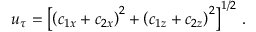Convert formula to latex. <formula><loc_0><loc_0><loc_500><loc_500>u _ { \tau } = \left [ \left ( c _ { 1 x } + c _ { 2 x } \right ) ^ { 2 } + \left ( c _ { 1 z } + c _ { 2 z } \right ) ^ { 2 } \right ] ^ { 1 / 2 } \, .</formula> 